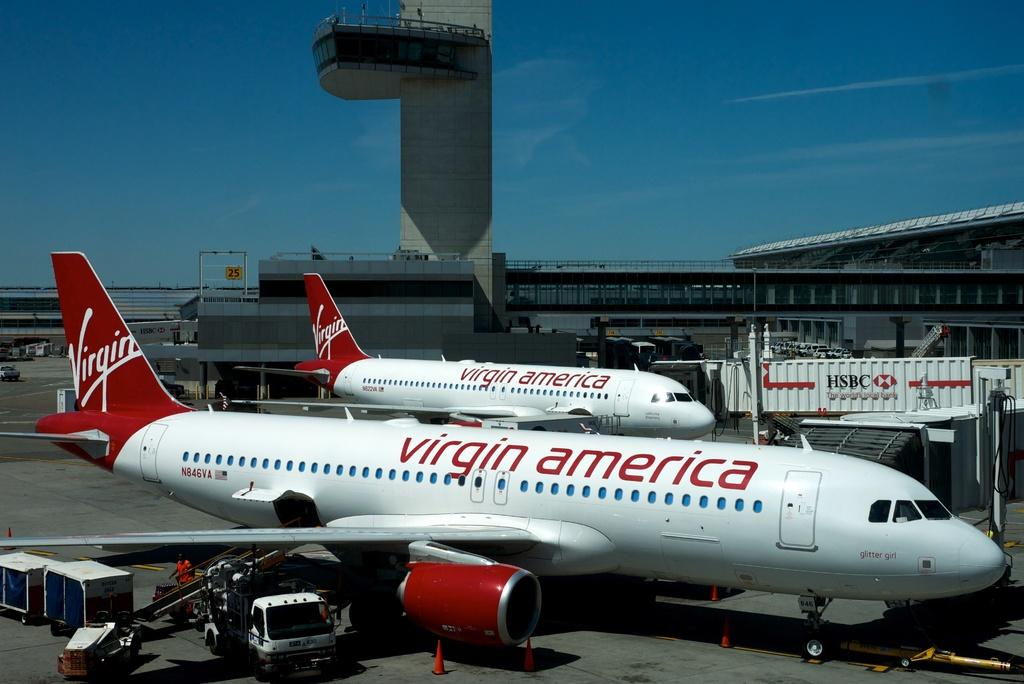<image>
Share a concise interpretation of the image provided. Two Virgin American airplanes are parked at terminal gates. 